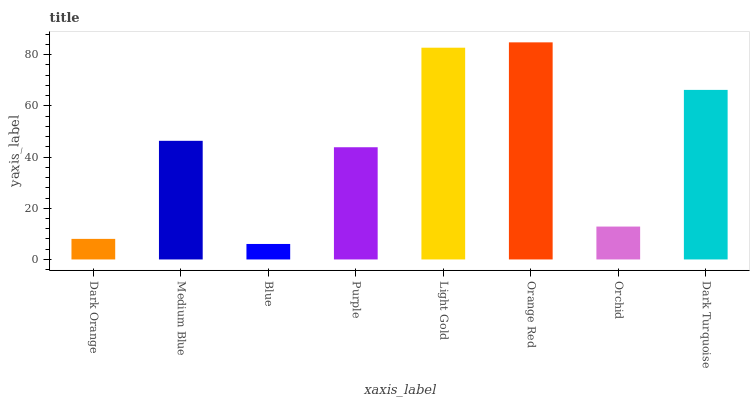Is Blue the minimum?
Answer yes or no. Yes. Is Orange Red the maximum?
Answer yes or no. Yes. Is Medium Blue the minimum?
Answer yes or no. No. Is Medium Blue the maximum?
Answer yes or no. No. Is Medium Blue greater than Dark Orange?
Answer yes or no. Yes. Is Dark Orange less than Medium Blue?
Answer yes or no. Yes. Is Dark Orange greater than Medium Blue?
Answer yes or no. No. Is Medium Blue less than Dark Orange?
Answer yes or no. No. Is Medium Blue the high median?
Answer yes or no. Yes. Is Purple the low median?
Answer yes or no. Yes. Is Dark Orange the high median?
Answer yes or no. No. Is Medium Blue the low median?
Answer yes or no. No. 